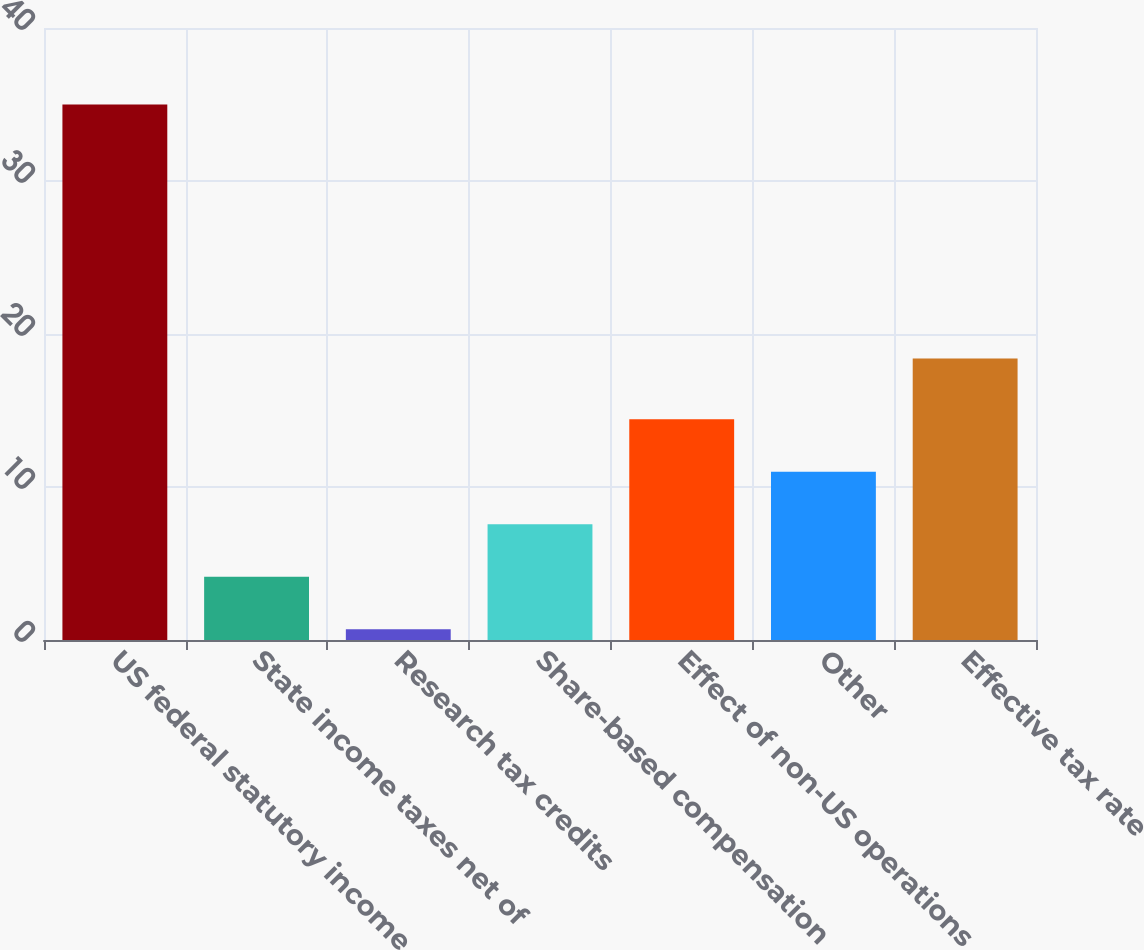<chart> <loc_0><loc_0><loc_500><loc_500><bar_chart><fcel>US federal statutory income<fcel>State income taxes net of<fcel>Research tax credits<fcel>Share-based compensation<fcel>Effect of non-US operations<fcel>Other<fcel>Effective tax rate<nl><fcel>35<fcel>4.13<fcel>0.7<fcel>7.56<fcel>14.42<fcel>10.99<fcel>18.4<nl></chart> 